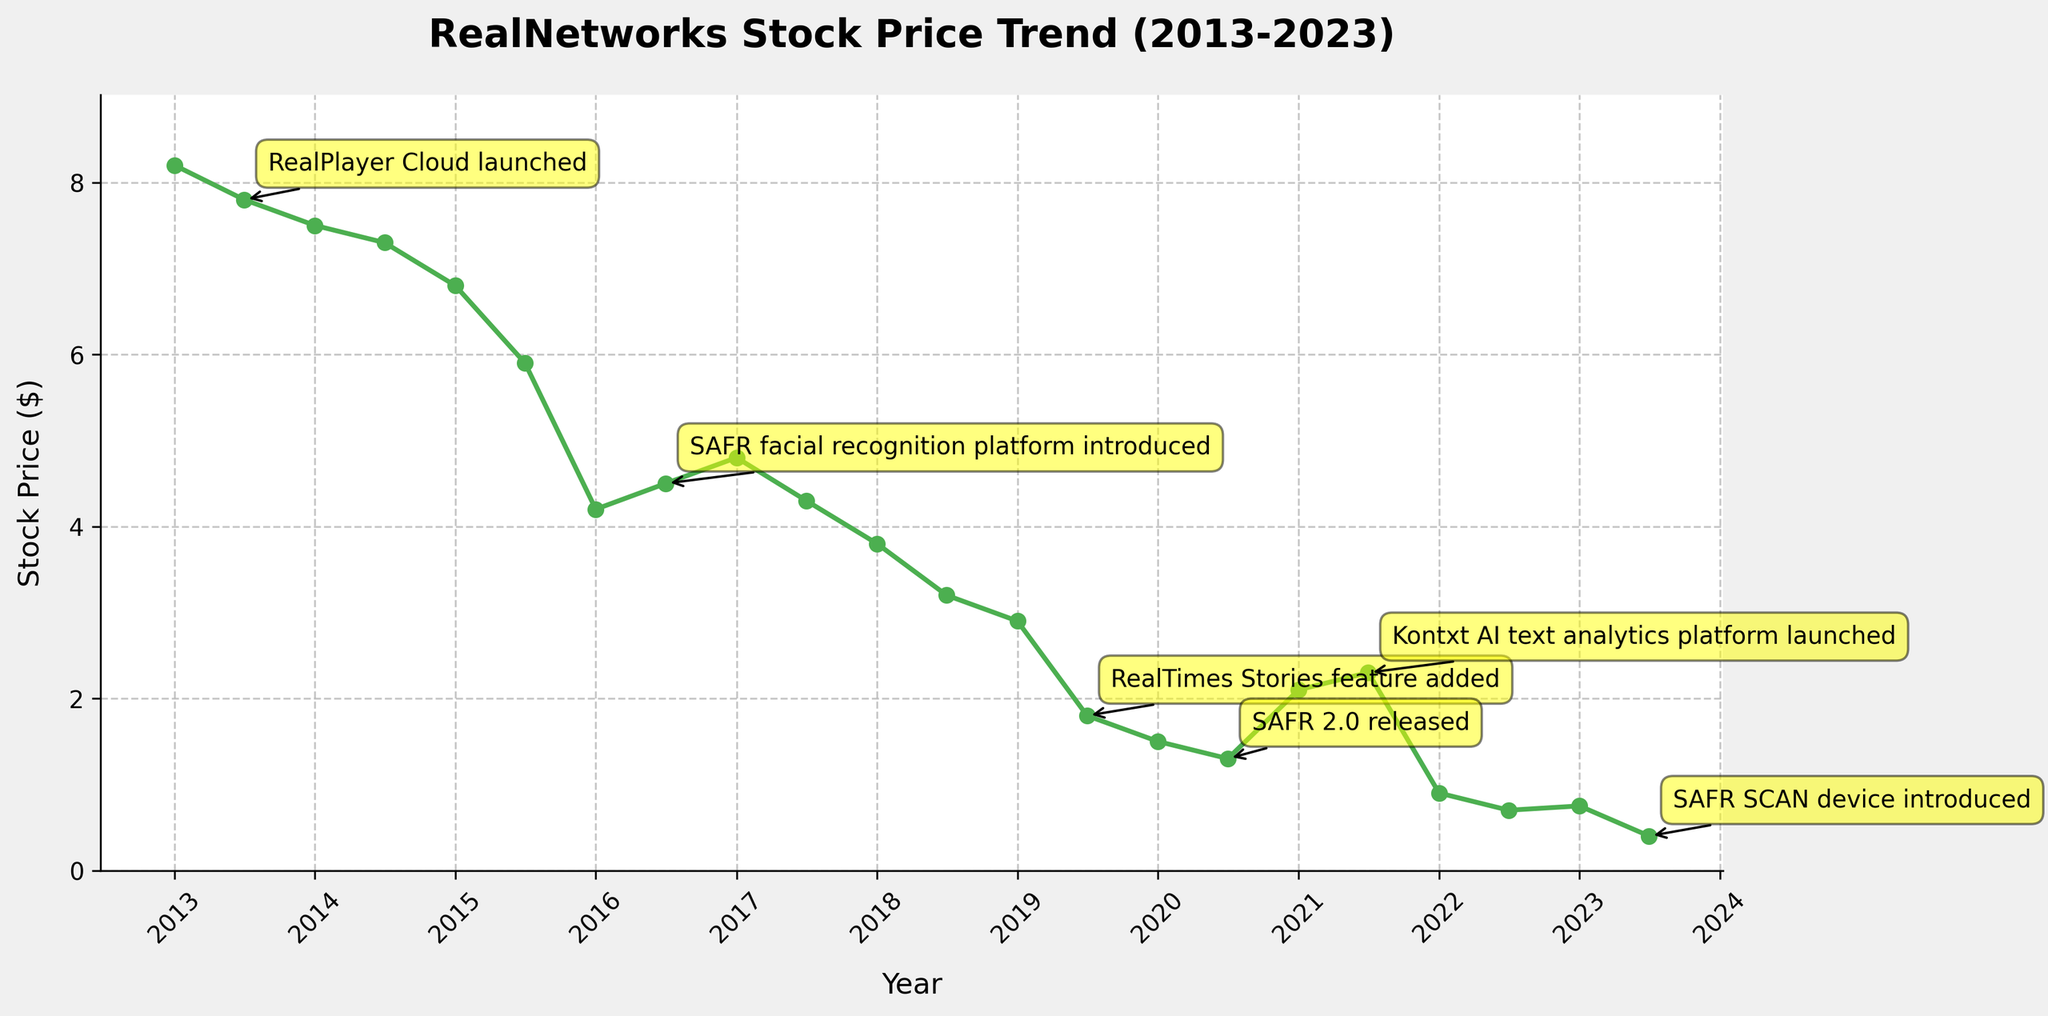What is the overall trend of RealNetworks' stock price from 2013 to 2023? The stock price shows a general downward trend from 2013 to 2023. Starting at $8.20 in January 2013, it drops to $0.40 by July 2023.
Answer: Downward What was the stock price immediately after RealPlayer Cloud was launched in July 2013? The stock price in July 2013 was $7.80 when RealPlayer Cloud was launched. This can be seen by locating the annotation for RealPlayer Cloud on the line graph and noting the stock price value at that time.
Answer: $7.80 Compare the stock price before and after the SAFR facial recognition platform was introduced in July 2016. Before SAFR was introduced in July 2016, the stock price was $4.20 in January 2016. After the introduction, it increased slightly to $4.50 by July 2016.
Answer: Increased How did the release of the RealTimes Stories feature in July 2019 affect the stock price? The stock price was $2.90 in January 2019, and it dropped to $1.80 by July 2019 when the RealTimes Stories feature was released, indicating a negative impact.
Answer: Negative impact What is the difference between the highest and lowest stock prices over the decade? The highest stock price was $8.20 in January 2013, and the lowest was $0.40 in July 2023. The difference is $8.20 - $0.40 = $7.80.
Answer: $7.80 Which major product release coincided with the highest stock price drop within six months? The RealPlayer Cloud release in July 2013 showed the largest drop in six months; from $8.20 in January 2013 to $7.80 in July 2013, decreasing further.
Answer: RealPlayer Cloud What was the stock price trend during the COVID-19 pandemic period starting from January 2020 to January 2021? The stock price was $1.50 in January 2020, dropping to $1.30 by July 2020, and rose to $2.10 by January 2021. The trend shows a drop followed by a rise.
Answer: Drop then rise After the launch of the Kontxt AI text analytics platform in July 2021, how did the stock price behave by July 2022? The stock price was $2.30 at the launch in July 2021 and dropped significantly to $0.70 by July 2022. This indicates a steep decline.
Answer: Steep decline Which product release appears to coincide with the most stable stock price period within a year of its release? The SAFR facial recognition platform released in July 2016 had a relatively stable stock price around $4.20 before and after its release, with minimal fluctuation within a year.
Answer: SAFR facial recognition platform Calculate the average stock price from 2013 to 2023. Add up all the stock prices and divide by the number of data points: (8.20 + 7.80 + 7.50 + 7.30 + 6.80 + 5.90 + 4.20 + 4.50 + 4.80 + 4.30 + 3.80 + 3.20 + 2.90 + 1.80 + 1.50 + 1.30 + 2.10 + 2.30 + 0.90 + 0.70 + 0.75 + 0.40) / 22 = 4.15.
Answer: $4.15 